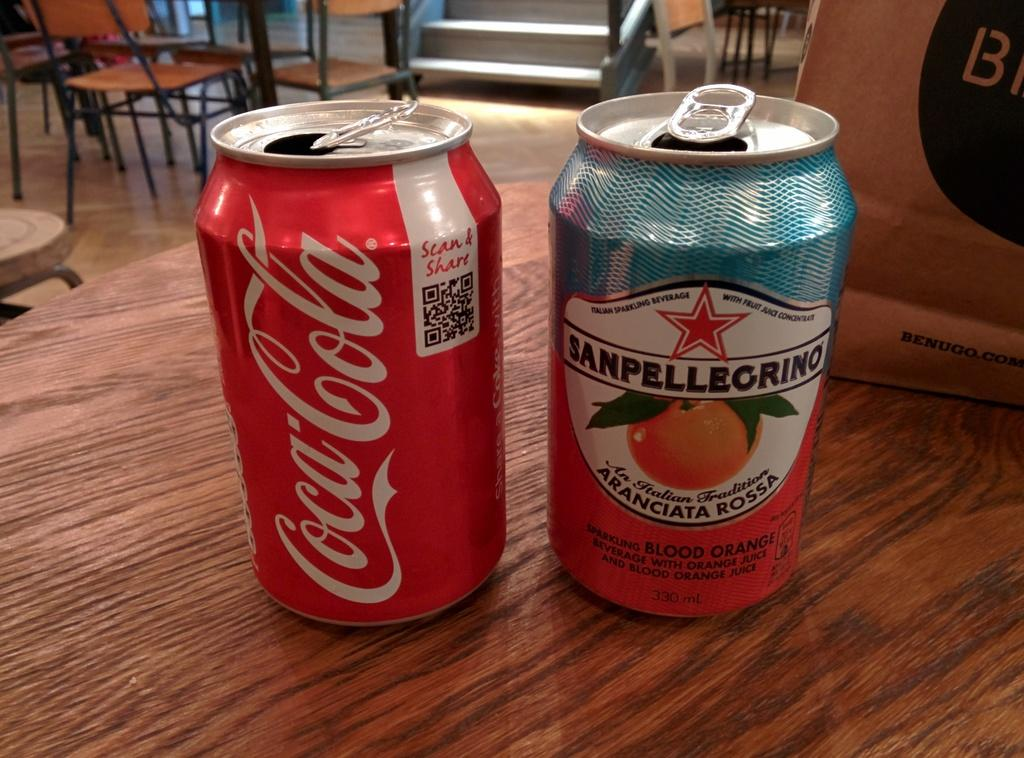<image>
Relay a brief, clear account of the picture shown. A can of Coca Cola is on a table next to another can. 